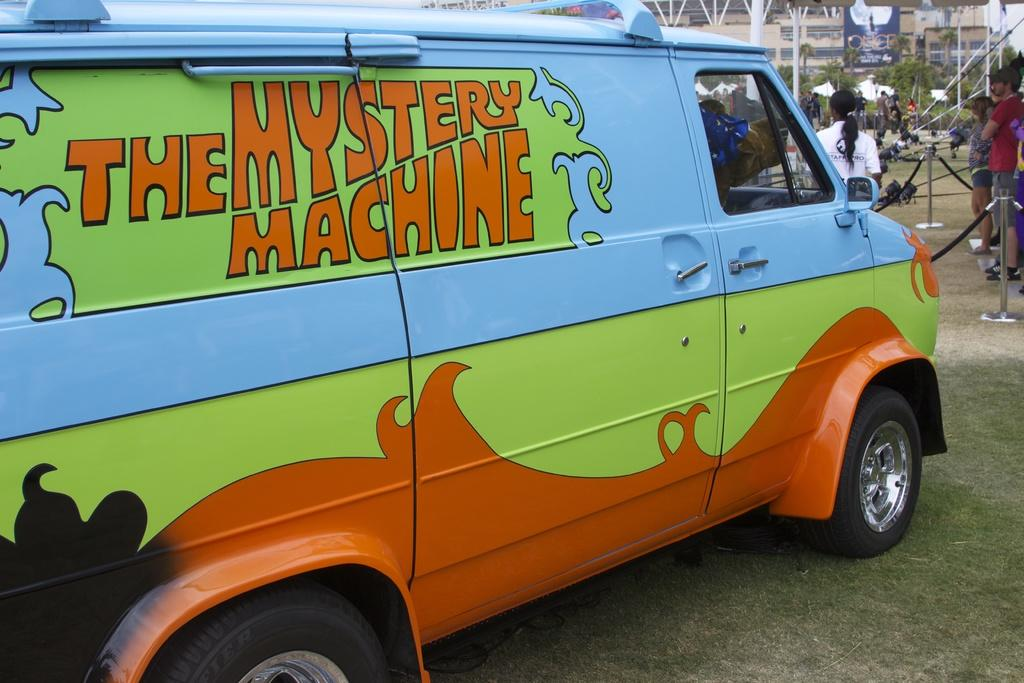What is the main subject of the image? There is a vehicle in the image. Can you describe the position of the vehicle? The vehicle is parked on the ground. Are there any people visible in the image? Yes, there are people standing on the top right side of the image. What type of care can be seen being provided to the clouds in the image? There are no clouds or care being provided to them in the image. What unit of measurement is used to determine the size of the vehicle in the image? The size of the vehicle cannot be determined from the image alone, so there is no unit of measurement mentioned. 